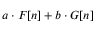<formula> <loc_0><loc_0><loc_500><loc_500>a \cdot F [ n ] + b \cdot G [ n ]</formula> 